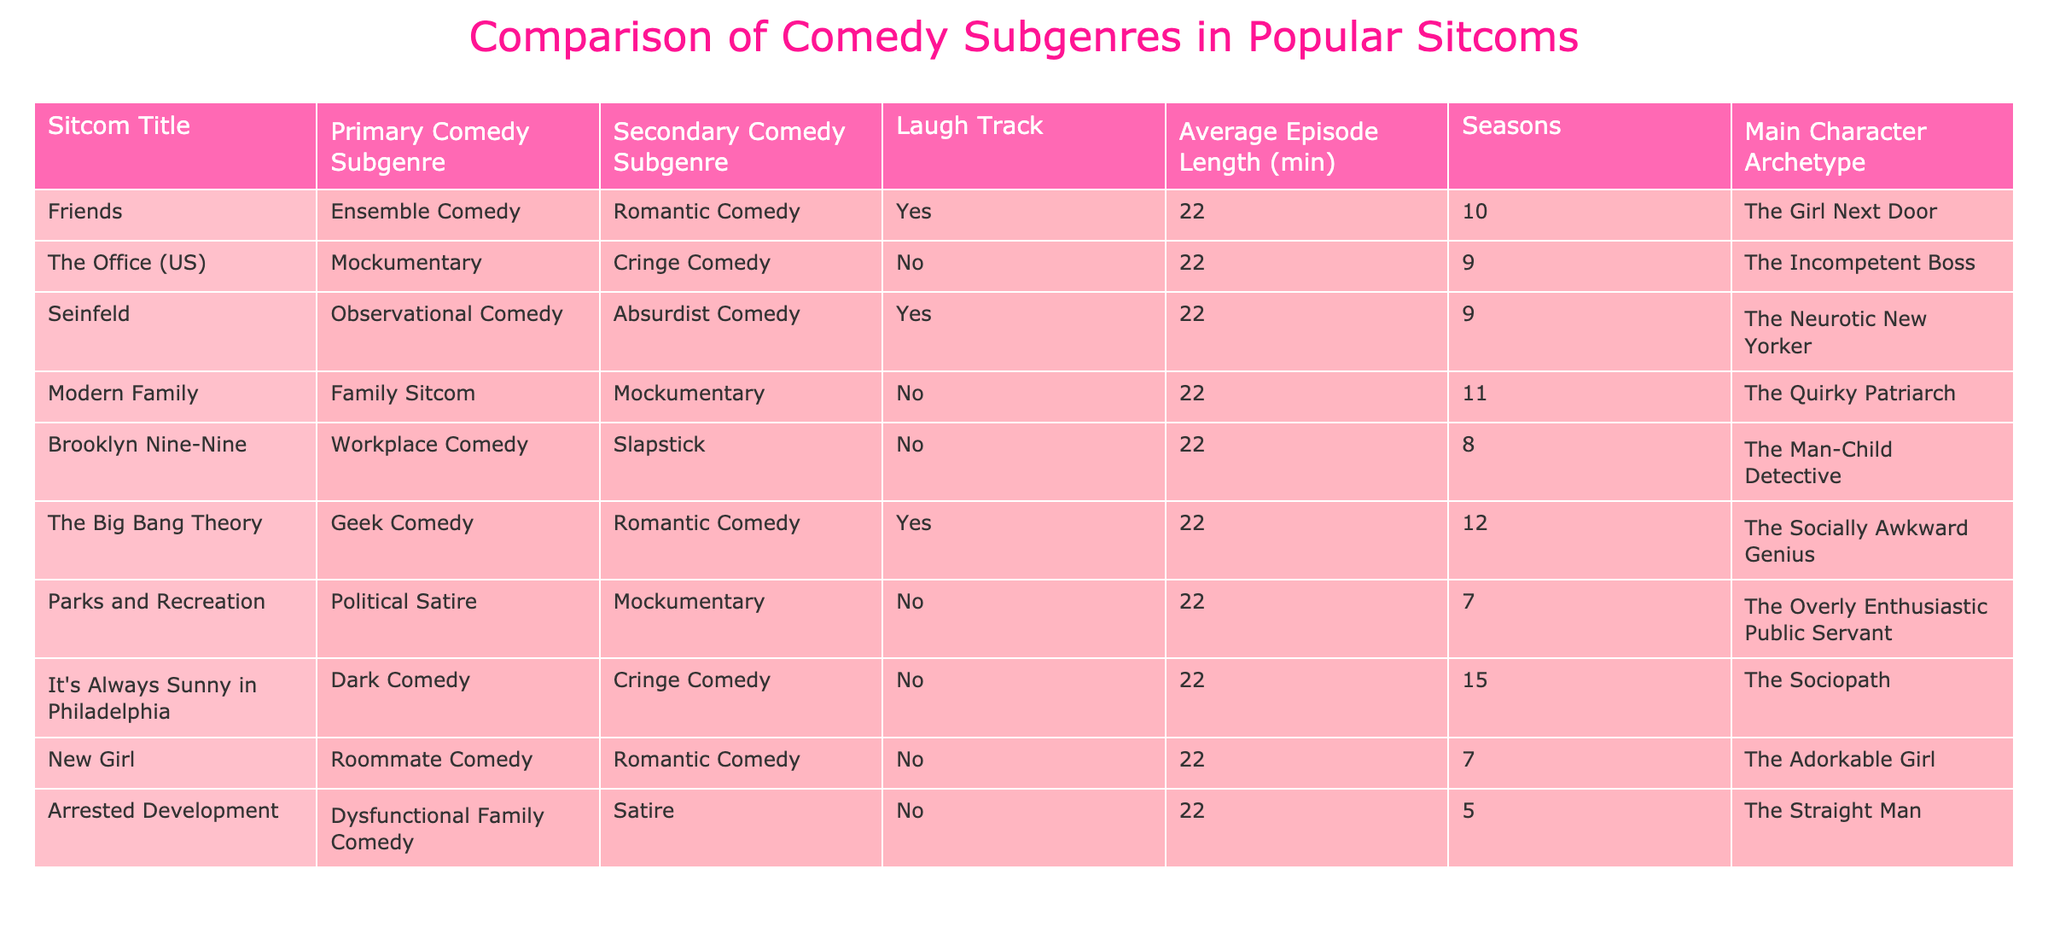What is the primary comedy subgenre of 'Friends'? 'Friends' has 'Ensemble Comedy' listed as its primary comedy subgenre. You can find this information directly in the first row of the table.
Answer: Ensemble Comedy How many seasons does 'The Office (US)' have? 'The Office (US)' is recorded in the table with a value of 9 in the 'Seasons' column.
Answer: 9 Which sitcom has a primary subgenre of 'Workplace Comedy'? From the table, 'Brooklyn Nine-Nine' is categorized under 'Workplace Comedy'. This can be found in the 'Primary Comedy Subgenre' column corresponding to 'Brooklyn Nine-Nine'.
Answer: Brooklyn Nine-Nine Are there any sitcoms in the table that have a laugh track? A quick scan of the 'Laugh Track' column reveals that 'Friends', 'Seinfeld', and 'The Big Bang Theory' all have 'Yes' for a laugh track. Therefore, the answer is affirmative.
Answer: Yes What is the average episode length of 'It's Always Sunny in Philadelphia'? From the table, 'It's Always Sunny in Philadelphia' shows an 'Average Episode Length' of 22 minutes. This information is in the corresponding row for that sitcom.
Answer: 22 How many sitcoms in total have a 'Romantic Comedy' as their primary subgenre? By checking the table, 'Friends', 'The Big Bang Theory', and 'New Girl' have 'Romantic Comedy' as their primary subgenre. That makes a total of 3 sitcoms.
Answer: 3 Is 'Parks and Recreation' considered an ensemble comedy? Looking at the 'Primary Comedy Subgenre' column for 'Parks and Recreation', there is listed 'Political Satire', not 'Ensemble Comedy'. This confirms that it does not belong to that category.
Answer: No Which sitcom has the most seasons, and what is that number? A glance through the table shows that 'The Big Bang Theory' has the highest number of seasons at 12. This is derived from the 'Seasons' column.
Answer: 12 If you add the seasons of 'Brooklyn Nine-Nine' and 'Parks and Recreation', what total do you get? 'Brooklyn Nine-Nine' has 8 seasons and 'Parks and Recreation' has 7 seasons, so the total is 8 + 7 = 15. Thus, they collectively have 15 seasons.
Answer: 15 